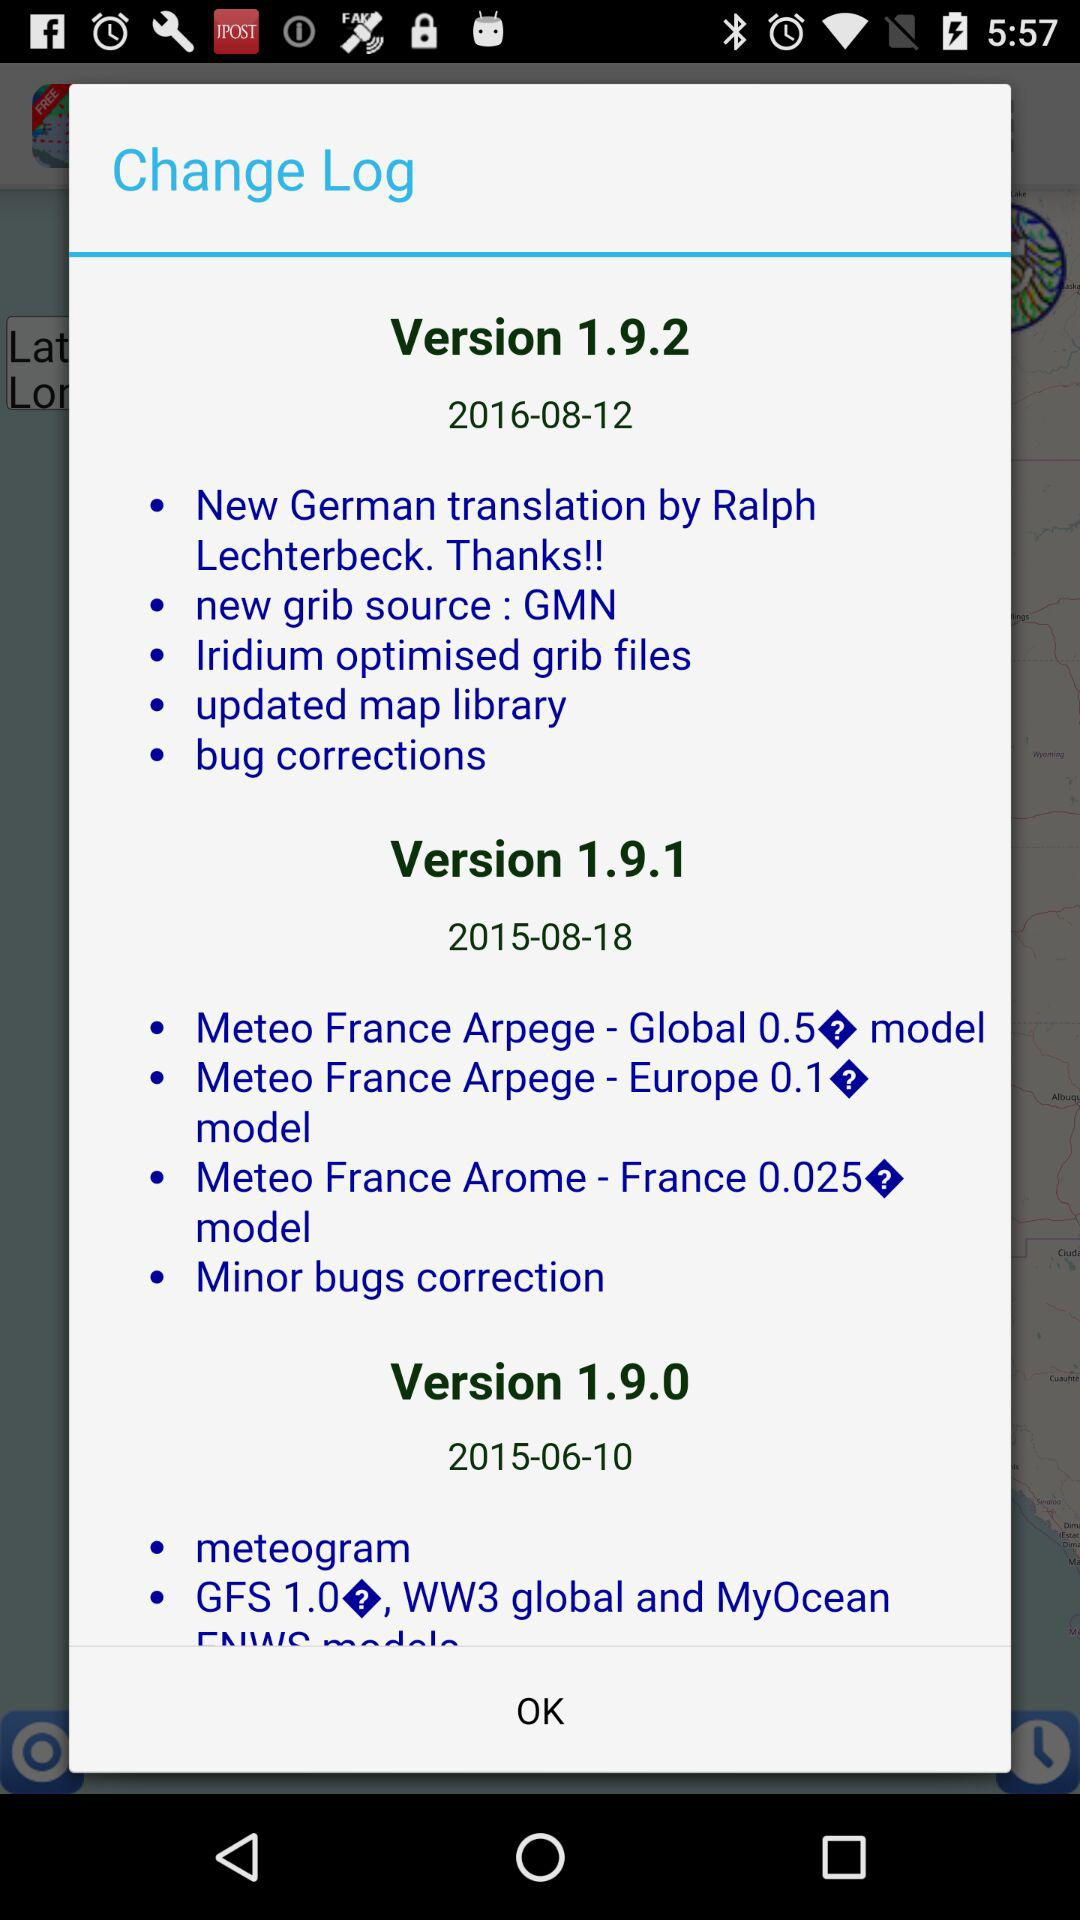In what version is the feature "New German translation" available? The feature "New German translation" is available in version 1.9.2. 